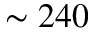<formula> <loc_0><loc_0><loc_500><loc_500>\sim 2 4 0</formula> 